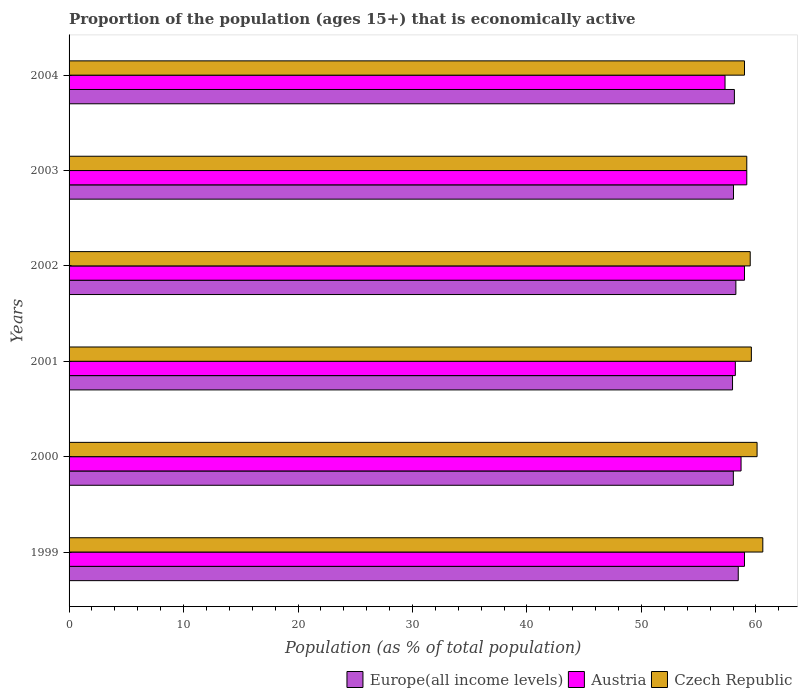How many different coloured bars are there?
Make the answer very short. 3. How many groups of bars are there?
Give a very brief answer. 6. Are the number of bars per tick equal to the number of legend labels?
Give a very brief answer. Yes. Are the number of bars on each tick of the Y-axis equal?
Your response must be concise. Yes. How many bars are there on the 3rd tick from the top?
Make the answer very short. 3. What is the label of the 2nd group of bars from the top?
Your answer should be compact. 2003. In how many cases, is the number of bars for a given year not equal to the number of legend labels?
Keep it short and to the point. 0. What is the proportion of the population that is economically active in Europe(all income levels) in 2001?
Give a very brief answer. 57.96. Across all years, what is the maximum proportion of the population that is economically active in Europe(all income levels)?
Keep it short and to the point. 58.46. What is the total proportion of the population that is economically active in Czech Republic in the graph?
Your answer should be very brief. 358. What is the difference between the proportion of the population that is economically active in Czech Republic in 1999 and that in 2001?
Provide a succinct answer. 1. What is the difference between the proportion of the population that is economically active in Czech Republic in 2001 and the proportion of the population that is economically active in Europe(all income levels) in 2002?
Give a very brief answer. 1.35. What is the average proportion of the population that is economically active in Austria per year?
Provide a short and direct response. 58.57. In the year 2000, what is the difference between the proportion of the population that is economically active in Europe(all income levels) and proportion of the population that is economically active in Austria?
Make the answer very short. -0.67. In how many years, is the proportion of the population that is economically active in Austria greater than 8 %?
Give a very brief answer. 6. What is the ratio of the proportion of the population that is economically active in Europe(all income levels) in 1999 to that in 2000?
Ensure brevity in your answer.  1.01. What is the difference between the highest and the second highest proportion of the population that is economically active in Austria?
Your answer should be very brief. 0.2. What is the difference between the highest and the lowest proportion of the population that is economically active in Europe(all income levels)?
Your answer should be compact. 0.5. In how many years, is the proportion of the population that is economically active in Czech Republic greater than the average proportion of the population that is economically active in Czech Republic taken over all years?
Your response must be concise. 2. What does the 3rd bar from the top in 2001 represents?
Provide a succinct answer. Europe(all income levels). What does the 3rd bar from the bottom in 2004 represents?
Ensure brevity in your answer.  Czech Republic. Are all the bars in the graph horizontal?
Make the answer very short. Yes. Are the values on the major ticks of X-axis written in scientific E-notation?
Your answer should be compact. No. Does the graph contain any zero values?
Your answer should be compact. No. How many legend labels are there?
Your response must be concise. 3. How are the legend labels stacked?
Offer a terse response. Horizontal. What is the title of the graph?
Provide a short and direct response. Proportion of the population (ages 15+) that is economically active. What is the label or title of the X-axis?
Give a very brief answer. Population (as % of total population). What is the label or title of the Y-axis?
Provide a short and direct response. Years. What is the Population (as % of total population) in Europe(all income levels) in 1999?
Your answer should be compact. 58.46. What is the Population (as % of total population) of Austria in 1999?
Your response must be concise. 59. What is the Population (as % of total population) of Czech Republic in 1999?
Offer a very short reply. 60.6. What is the Population (as % of total population) of Europe(all income levels) in 2000?
Provide a succinct answer. 58.03. What is the Population (as % of total population) of Austria in 2000?
Give a very brief answer. 58.7. What is the Population (as % of total population) of Czech Republic in 2000?
Ensure brevity in your answer.  60.1. What is the Population (as % of total population) of Europe(all income levels) in 2001?
Your response must be concise. 57.96. What is the Population (as % of total population) of Austria in 2001?
Your response must be concise. 58.2. What is the Population (as % of total population) in Czech Republic in 2001?
Give a very brief answer. 59.6. What is the Population (as % of total population) in Europe(all income levels) in 2002?
Make the answer very short. 58.25. What is the Population (as % of total population) in Austria in 2002?
Your response must be concise. 59. What is the Population (as % of total population) of Czech Republic in 2002?
Provide a short and direct response. 59.5. What is the Population (as % of total population) in Europe(all income levels) in 2003?
Your answer should be very brief. 58.04. What is the Population (as % of total population) of Austria in 2003?
Your answer should be very brief. 59.2. What is the Population (as % of total population) of Czech Republic in 2003?
Offer a very short reply. 59.2. What is the Population (as % of total population) of Europe(all income levels) in 2004?
Offer a very short reply. 58.12. What is the Population (as % of total population) of Austria in 2004?
Keep it short and to the point. 57.3. Across all years, what is the maximum Population (as % of total population) in Europe(all income levels)?
Keep it short and to the point. 58.46. Across all years, what is the maximum Population (as % of total population) in Austria?
Your answer should be very brief. 59.2. Across all years, what is the maximum Population (as % of total population) in Czech Republic?
Offer a terse response. 60.6. Across all years, what is the minimum Population (as % of total population) of Europe(all income levels)?
Ensure brevity in your answer.  57.96. Across all years, what is the minimum Population (as % of total population) of Austria?
Your answer should be compact. 57.3. What is the total Population (as % of total population) in Europe(all income levels) in the graph?
Your answer should be very brief. 348.84. What is the total Population (as % of total population) in Austria in the graph?
Give a very brief answer. 351.4. What is the total Population (as % of total population) in Czech Republic in the graph?
Offer a very short reply. 358. What is the difference between the Population (as % of total population) of Europe(all income levels) in 1999 and that in 2000?
Ensure brevity in your answer.  0.43. What is the difference between the Population (as % of total population) in Austria in 1999 and that in 2000?
Provide a short and direct response. 0.3. What is the difference between the Population (as % of total population) of Europe(all income levels) in 1999 and that in 2001?
Provide a short and direct response. 0.5. What is the difference between the Population (as % of total population) in Austria in 1999 and that in 2001?
Your answer should be compact. 0.8. What is the difference between the Population (as % of total population) of Czech Republic in 1999 and that in 2001?
Keep it short and to the point. 1. What is the difference between the Population (as % of total population) of Europe(all income levels) in 1999 and that in 2002?
Keep it short and to the point. 0.21. What is the difference between the Population (as % of total population) of Austria in 1999 and that in 2002?
Make the answer very short. 0. What is the difference between the Population (as % of total population) in Europe(all income levels) in 1999 and that in 2003?
Your answer should be compact. 0.42. What is the difference between the Population (as % of total population) of Europe(all income levels) in 1999 and that in 2004?
Make the answer very short. 0.34. What is the difference between the Population (as % of total population) of Europe(all income levels) in 2000 and that in 2001?
Provide a succinct answer. 0.07. What is the difference between the Population (as % of total population) in Europe(all income levels) in 2000 and that in 2002?
Provide a short and direct response. -0.22. What is the difference between the Population (as % of total population) of Austria in 2000 and that in 2002?
Offer a very short reply. -0.3. What is the difference between the Population (as % of total population) in Europe(all income levels) in 2000 and that in 2003?
Give a very brief answer. -0.01. What is the difference between the Population (as % of total population) in Czech Republic in 2000 and that in 2003?
Provide a succinct answer. 0.9. What is the difference between the Population (as % of total population) of Europe(all income levels) in 2000 and that in 2004?
Keep it short and to the point. -0.09. What is the difference between the Population (as % of total population) in Austria in 2000 and that in 2004?
Offer a terse response. 1.4. What is the difference between the Population (as % of total population) of Europe(all income levels) in 2001 and that in 2002?
Ensure brevity in your answer.  -0.29. What is the difference between the Population (as % of total population) of Czech Republic in 2001 and that in 2002?
Ensure brevity in your answer.  0.1. What is the difference between the Population (as % of total population) in Europe(all income levels) in 2001 and that in 2003?
Provide a short and direct response. -0.08. What is the difference between the Population (as % of total population) in Czech Republic in 2001 and that in 2003?
Keep it short and to the point. 0.4. What is the difference between the Population (as % of total population) of Europe(all income levels) in 2001 and that in 2004?
Give a very brief answer. -0.16. What is the difference between the Population (as % of total population) of Europe(all income levels) in 2002 and that in 2003?
Your response must be concise. 0.21. What is the difference between the Population (as % of total population) of Austria in 2002 and that in 2003?
Keep it short and to the point. -0.2. What is the difference between the Population (as % of total population) in Czech Republic in 2002 and that in 2003?
Provide a succinct answer. 0.3. What is the difference between the Population (as % of total population) of Europe(all income levels) in 2002 and that in 2004?
Offer a terse response. 0.13. What is the difference between the Population (as % of total population) of Austria in 2002 and that in 2004?
Keep it short and to the point. 1.7. What is the difference between the Population (as % of total population) in Czech Republic in 2002 and that in 2004?
Offer a terse response. 0.5. What is the difference between the Population (as % of total population) in Europe(all income levels) in 2003 and that in 2004?
Keep it short and to the point. -0.08. What is the difference between the Population (as % of total population) of Austria in 2003 and that in 2004?
Provide a short and direct response. 1.9. What is the difference between the Population (as % of total population) of Czech Republic in 2003 and that in 2004?
Make the answer very short. 0.2. What is the difference between the Population (as % of total population) in Europe(all income levels) in 1999 and the Population (as % of total population) in Austria in 2000?
Offer a terse response. -0.24. What is the difference between the Population (as % of total population) of Europe(all income levels) in 1999 and the Population (as % of total population) of Czech Republic in 2000?
Your answer should be very brief. -1.64. What is the difference between the Population (as % of total population) in Austria in 1999 and the Population (as % of total population) in Czech Republic in 2000?
Your answer should be very brief. -1.1. What is the difference between the Population (as % of total population) of Europe(all income levels) in 1999 and the Population (as % of total population) of Austria in 2001?
Provide a succinct answer. 0.26. What is the difference between the Population (as % of total population) in Europe(all income levels) in 1999 and the Population (as % of total population) in Czech Republic in 2001?
Provide a short and direct response. -1.14. What is the difference between the Population (as % of total population) in Austria in 1999 and the Population (as % of total population) in Czech Republic in 2001?
Make the answer very short. -0.6. What is the difference between the Population (as % of total population) in Europe(all income levels) in 1999 and the Population (as % of total population) in Austria in 2002?
Your answer should be very brief. -0.54. What is the difference between the Population (as % of total population) of Europe(all income levels) in 1999 and the Population (as % of total population) of Czech Republic in 2002?
Your answer should be very brief. -1.04. What is the difference between the Population (as % of total population) of Austria in 1999 and the Population (as % of total population) of Czech Republic in 2002?
Provide a succinct answer. -0.5. What is the difference between the Population (as % of total population) in Europe(all income levels) in 1999 and the Population (as % of total population) in Austria in 2003?
Keep it short and to the point. -0.74. What is the difference between the Population (as % of total population) of Europe(all income levels) in 1999 and the Population (as % of total population) of Czech Republic in 2003?
Give a very brief answer. -0.74. What is the difference between the Population (as % of total population) of Austria in 1999 and the Population (as % of total population) of Czech Republic in 2003?
Your answer should be compact. -0.2. What is the difference between the Population (as % of total population) in Europe(all income levels) in 1999 and the Population (as % of total population) in Austria in 2004?
Your answer should be very brief. 1.16. What is the difference between the Population (as % of total population) of Europe(all income levels) in 1999 and the Population (as % of total population) of Czech Republic in 2004?
Offer a terse response. -0.54. What is the difference between the Population (as % of total population) in Europe(all income levels) in 2000 and the Population (as % of total population) in Austria in 2001?
Provide a short and direct response. -0.17. What is the difference between the Population (as % of total population) of Europe(all income levels) in 2000 and the Population (as % of total population) of Czech Republic in 2001?
Give a very brief answer. -1.57. What is the difference between the Population (as % of total population) in Austria in 2000 and the Population (as % of total population) in Czech Republic in 2001?
Ensure brevity in your answer.  -0.9. What is the difference between the Population (as % of total population) of Europe(all income levels) in 2000 and the Population (as % of total population) of Austria in 2002?
Offer a very short reply. -0.97. What is the difference between the Population (as % of total population) in Europe(all income levels) in 2000 and the Population (as % of total population) in Czech Republic in 2002?
Make the answer very short. -1.47. What is the difference between the Population (as % of total population) of Austria in 2000 and the Population (as % of total population) of Czech Republic in 2002?
Provide a succinct answer. -0.8. What is the difference between the Population (as % of total population) of Europe(all income levels) in 2000 and the Population (as % of total population) of Austria in 2003?
Give a very brief answer. -1.17. What is the difference between the Population (as % of total population) in Europe(all income levels) in 2000 and the Population (as % of total population) in Czech Republic in 2003?
Offer a terse response. -1.17. What is the difference between the Population (as % of total population) of Austria in 2000 and the Population (as % of total population) of Czech Republic in 2003?
Offer a very short reply. -0.5. What is the difference between the Population (as % of total population) of Europe(all income levels) in 2000 and the Population (as % of total population) of Austria in 2004?
Your response must be concise. 0.73. What is the difference between the Population (as % of total population) of Europe(all income levels) in 2000 and the Population (as % of total population) of Czech Republic in 2004?
Give a very brief answer. -0.97. What is the difference between the Population (as % of total population) of Europe(all income levels) in 2001 and the Population (as % of total population) of Austria in 2002?
Provide a short and direct response. -1.04. What is the difference between the Population (as % of total population) in Europe(all income levels) in 2001 and the Population (as % of total population) in Czech Republic in 2002?
Your response must be concise. -1.54. What is the difference between the Population (as % of total population) of Europe(all income levels) in 2001 and the Population (as % of total population) of Austria in 2003?
Make the answer very short. -1.24. What is the difference between the Population (as % of total population) in Europe(all income levels) in 2001 and the Population (as % of total population) in Czech Republic in 2003?
Offer a terse response. -1.24. What is the difference between the Population (as % of total population) of Austria in 2001 and the Population (as % of total population) of Czech Republic in 2003?
Give a very brief answer. -1. What is the difference between the Population (as % of total population) in Europe(all income levels) in 2001 and the Population (as % of total population) in Austria in 2004?
Your answer should be compact. 0.66. What is the difference between the Population (as % of total population) of Europe(all income levels) in 2001 and the Population (as % of total population) of Czech Republic in 2004?
Provide a succinct answer. -1.04. What is the difference between the Population (as % of total population) of Austria in 2001 and the Population (as % of total population) of Czech Republic in 2004?
Provide a succinct answer. -0.8. What is the difference between the Population (as % of total population) of Europe(all income levels) in 2002 and the Population (as % of total population) of Austria in 2003?
Your answer should be compact. -0.95. What is the difference between the Population (as % of total population) in Europe(all income levels) in 2002 and the Population (as % of total population) in Czech Republic in 2003?
Your response must be concise. -0.95. What is the difference between the Population (as % of total population) of Europe(all income levels) in 2002 and the Population (as % of total population) of Austria in 2004?
Provide a succinct answer. 0.95. What is the difference between the Population (as % of total population) in Europe(all income levels) in 2002 and the Population (as % of total population) in Czech Republic in 2004?
Your response must be concise. -0.75. What is the difference between the Population (as % of total population) of Europe(all income levels) in 2003 and the Population (as % of total population) of Austria in 2004?
Offer a very short reply. 0.74. What is the difference between the Population (as % of total population) of Europe(all income levels) in 2003 and the Population (as % of total population) of Czech Republic in 2004?
Your answer should be very brief. -0.96. What is the difference between the Population (as % of total population) of Austria in 2003 and the Population (as % of total population) of Czech Republic in 2004?
Your response must be concise. 0.2. What is the average Population (as % of total population) in Europe(all income levels) per year?
Provide a short and direct response. 58.14. What is the average Population (as % of total population) of Austria per year?
Provide a succinct answer. 58.57. What is the average Population (as % of total population) in Czech Republic per year?
Give a very brief answer. 59.67. In the year 1999, what is the difference between the Population (as % of total population) in Europe(all income levels) and Population (as % of total population) in Austria?
Your answer should be very brief. -0.54. In the year 1999, what is the difference between the Population (as % of total population) of Europe(all income levels) and Population (as % of total population) of Czech Republic?
Make the answer very short. -2.14. In the year 1999, what is the difference between the Population (as % of total population) of Austria and Population (as % of total population) of Czech Republic?
Your response must be concise. -1.6. In the year 2000, what is the difference between the Population (as % of total population) in Europe(all income levels) and Population (as % of total population) in Austria?
Make the answer very short. -0.67. In the year 2000, what is the difference between the Population (as % of total population) of Europe(all income levels) and Population (as % of total population) of Czech Republic?
Make the answer very short. -2.07. In the year 2001, what is the difference between the Population (as % of total population) of Europe(all income levels) and Population (as % of total population) of Austria?
Your response must be concise. -0.24. In the year 2001, what is the difference between the Population (as % of total population) in Europe(all income levels) and Population (as % of total population) in Czech Republic?
Offer a terse response. -1.64. In the year 2001, what is the difference between the Population (as % of total population) in Austria and Population (as % of total population) in Czech Republic?
Provide a succinct answer. -1.4. In the year 2002, what is the difference between the Population (as % of total population) of Europe(all income levels) and Population (as % of total population) of Austria?
Provide a succinct answer. -0.75. In the year 2002, what is the difference between the Population (as % of total population) in Europe(all income levels) and Population (as % of total population) in Czech Republic?
Your answer should be very brief. -1.25. In the year 2002, what is the difference between the Population (as % of total population) of Austria and Population (as % of total population) of Czech Republic?
Provide a succinct answer. -0.5. In the year 2003, what is the difference between the Population (as % of total population) of Europe(all income levels) and Population (as % of total population) of Austria?
Your answer should be very brief. -1.16. In the year 2003, what is the difference between the Population (as % of total population) in Europe(all income levels) and Population (as % of total population) in Czech Republic?
Provide a short and direct response. -1.16. In the year 2004, what is the difference between the Population (as % of total population) in Europe(all income levels) and Population (as % of total population) in Austria?
Your response must be concise. 0.82. In the year 2004, what is the difference between the Population (as % of total population) in Europe(all income levels) and Population (as % of total population) in Czech Republic?
Make the answer very short. -0.88. What is the ratio of the Population (as % of total population) of Europe(all income levels) in 1999 to that in 2000?
Provide a short and direct response. 1.01. What is the ratio of the Population (as % of total population) of Czech Republic in 1999 to that in 2000?
Provide a succinct answer. 1.01. What is the ratio of the Population (as % of total population) of Europe(all income levels) in 1999 to that in 2001?
Give a very brief answer. 1.01. What is the ratio of the Population (as % of total population) of Austria in 1999 to that in 2001?
Provide a succinct answer. 1.01. What is the ratio of the Population (as % of total population) of Czech Republic in 1999 to that in 2001?
Provide a succinct answer. 1.02. What is the ratio of the Population (as % of total population) in Europe(all income levels) in 1999 to that in 2002?
Make the answer very short. 1. What is the ratio of the Population (as % of total population) in Czech Republic in 1999 to that in 2002?
Keep it short and to the point. 1.02. What is the ratio of the Population (as % of total population) of Czech Republic in 1999 to that in 2003?
Your response must be concise. 1.02. What is the ratio of the Population (as % of total population) in Europe(all income levels) in 1999 to that in 2004?
Your answer should be very brief. 1.01. What is the ratio of the Population (as % of total population) of Austria in 1999 to that in 2004?
Provide a short and direct response. 1.03. What is the ratio of the Population (as % of total population) of Czech Republic in 1999 to that in 2004?
Your response must be concise. 1.03. What is the ratio of the Population (as % of total population) in Europe(all income levels) in 2000 to that in 2001?
Your answer should be very brief. 1. What is the ratio of the Population (as % of total population) in Austria in 2000 to that in 2001?
Offer a terse response. 1.01. What is the ratio of the Population (as % of total population) of Czech Republic in 2000 to that in 2001?
Offer a terse response. 1.01. What is the ratio of the Population (as % of total population) of Europe(all income levels) in 2000 to that in 2002?
Your response must be concise. 1. What is the ratio of the Population (as % of total population) of Czech Republic in 2000 to that in 2002?
Make the answer very short. 1.01. What is the ratio of the Population (as % of total population) of Austria in 2000 to that in 2003?
Give a very brief answer. 0.99. What is the ratio of the Population (as % of total population) of Czech Republic in 2000 to that in 2003?
Offer a very short reply. 1.02. What is the ratio of the Population (as % of total population) of Europe(all income levels) in 2000 to that in 2004?
Your response must be concise. 1. What is the ratio of the Population (as % of total population) in Austria in 2000 to that in 2004?
Keep it short and to the point. 1.02. What is the ratio of the Population (as % of total population) in Czech Republic in 2000 to that in 2004?
Offer a very short reply. 1.02. What is the ratio of the Population (as % of total population) in Europe(all income levels) in 2001 to that in 2002?
Make the answer very short. 0.99. What is the ratio of the Population (as % of total population) in Austria in 2001 to that in 2002?
Ensure brevity in your answer.  0.99. What is the ratio of the Population (as % of total population) in Europe(all income levels) in 2001 to that in 2003?
Provide a succinct answer. 1. What is the ratio of the Population (as % of total population) in Austria in 2001 to that in 2003?
Provide a short and direct response. 0.98. What is the ratio of the Population (as % of total population) of Czech Republic in 2001 to that in 2003?
Offer a terse response. 1.01. What is the ratio of the Population (as % of total population) of Europe(all income levels) in 2001 to that in 2004?
Make the answer very short. 1. What is the ratio of the Population (as % of total population) of Austria in 2001 to that in 2004?
Your response must be concise. 1.02. What is the ratio of the Population (as % of total population) in Czech Republic in 2001 to that in 2004?
Your answer should be very brief. 1.01. What is the ratio of the Population (as % of total population) in Europe(all income levels) in 2002 to that in 2003?
Offer a very short reply. 1. What is the ratio of the Population (as % of total population) of Czech Republic in 2002 to that in 2003?
Provide a succinct answer. 1.01. What is the ratio of the Population (as % of total population) in Austria in 2002 to that in 2004?
Your answer should be very brief. 1.03. What is the ratio of the Population (as % of total population) in Czech Republic in 2002 to that in 2004?
Make the answer very short. 1.01. What is the ratio of the Population (as % of total population) of Europe(all income levels) in 2003 to that in 2004?
Your answer should be very brief. 1. What is the ratio of the Population (as % of total population) of Austria in 2003 to that in 2004?
Give a very brief answer. 1.03. What is the difference between the highest and the second highest Population (as % of total population) in Europe(all income levels)?
Keep it short and to the point. 0.21. What is the difference between the highest and the lowest Population (as % of total population) of Europe(all income levels)?
Keep it short and to the point. 0.5. What is the difference between the highest and the lowest Population (as % of total population) in Austria?
Your answer should be very brief. 1.9. What is the difference between the highest and the lowest Population (as % of total population) in Czech Republic?
Make the answer very short. 1.6. 